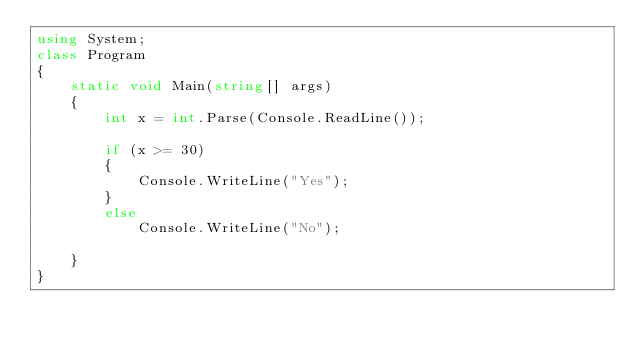Convert code to text. <code><loc_0><loc_0><loc_500><loc_500><_C#_>using System;
class Program
{
    static void Main(string[] args)
    {
        int x = int.Parse(Console.ReadLine());

        if (x >= 30)
        {
            Console.WriteLine("Yes");
        }
        else
            Console.WriteLine("No");

    }
}


</code> 